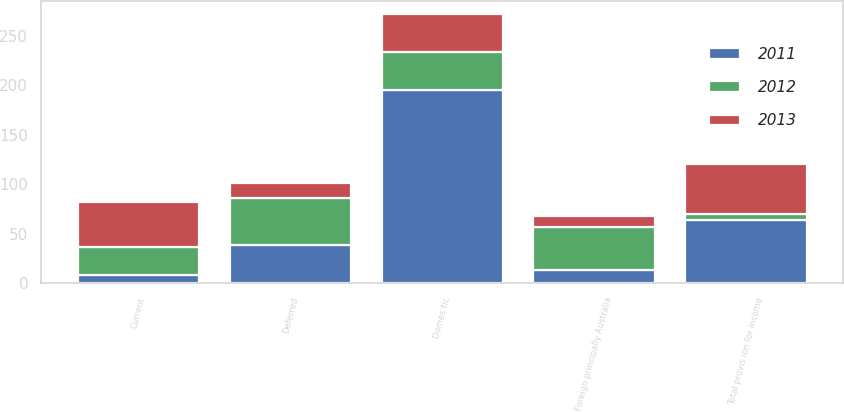<chart> <loc_0><loc_0><loc_500><loc_500><stacked_bar_chart><ecel><fcel>Domes tic<fcel>Foreign principally Australia<fcel>Current<fcel>Deferred<fcel>Total provis ion for income<nl><fcel>2012<fcel>38.4<fcel>43.7<fcel>29<fcel>47.7<fcel>5.9<nl><fcel>2013<fcel>38.4<fcel>10.6<fcel>45.4<fcel>14.6<fcel>50.3<nl><fcel>2011<fcel>194.7<fcel>13.1<fcel>7.8<fcel>38.4<fcel>63.7<nl></chart> 